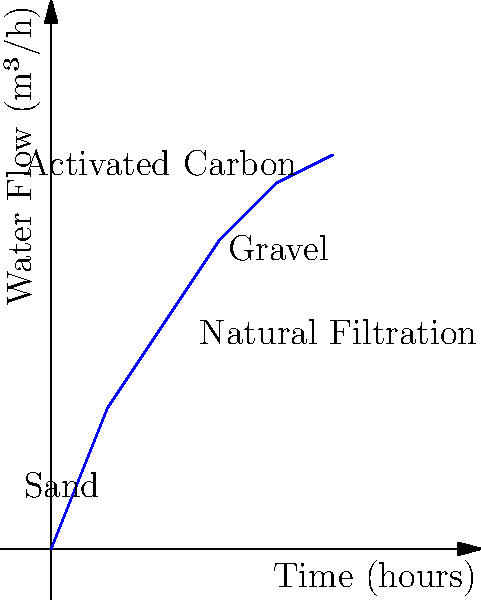At an eco-friendly campsite, a natural water treatment system is designed to purify water without using synthetic chemicals. The graph shows the water flow rate through the system over time. Calculate the total volume of water treated during the 5-hour period, assuming the flow rate follows the curve shown. To calculate the total volume of water treated, we need to find the area under the curve. Since the curve is not a simple geometric shape, we'll use the trapezoidal rule to approximate the area.

Steps:
1. Divide the area into 5 trapezoids (0-1h, 1-2h, 2-3h, 3-4h, 4-5h).
2. Calculate the area of each trapezoid using the formula: $A = \frac{1}{2}(b_1 + b_2)h$, where $b_1$ and $b_2$ are the parallel sides and $h$ is the height.
3. Sum the areas of all trapezoids.

Calculations:
1. 0-1h: $A_1 = \frac{1}{2}(0 + 2.5) \cdot 1 = 1.25$ m³
2. 1-2h: $A_2 = \frac{1}{2}(2.5 + 4) \cdot 1 = 3.25$ m³
3. 2-3h: $A_3 = \frac{1}{2}(4 + 5.5) \cdot 1 = 4.75$ m³
4. 3-4h: $A_4 = \frac{1}{2}(5.5 + 6.5) \cdot 1 = 6$ m³
5. 4-5h: $A_5 = \frac{1}{2}(6.5 + 7) \cdot 1 = 6.75$ m³

Total volume = $A_1 + A_2 + A_3 + A_4 + A_5$
              = $1.25 + 3.25 + 4.75 + 6 + 6.75$
              = $22$ m³
Answer: 22 m³ 